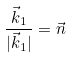Convert formula to latex. <formula><loc_0><loc_0><loc_500><loc_500>\frac { \vec { k } _ { 1 } } { | \vec { k } _ { 1 } | } = \vec { n }</formula> 